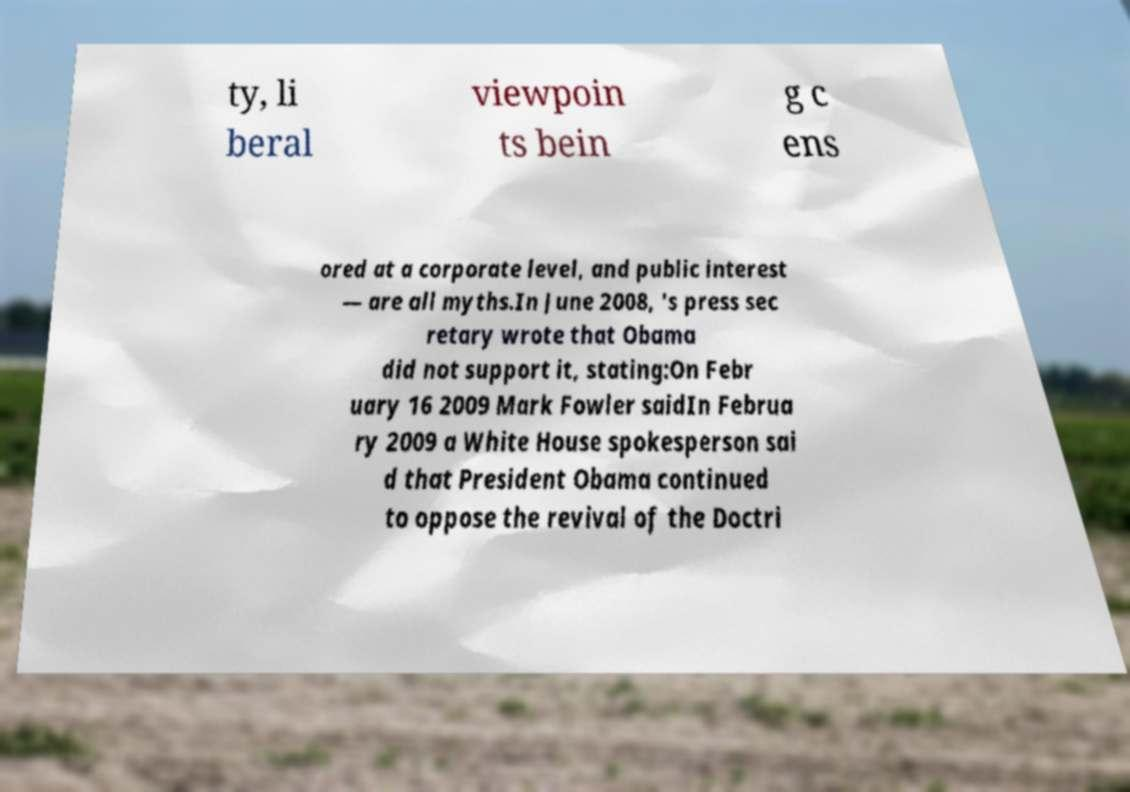Please identify and transcribe the text found in this image. ty, li beral viewpoin ts bein g c ens ored at a corporate level, and public interest — are all myths.In June 2008, 's press sec retary wrote that Obama did not support it, stating:On Febr uary 16 2009 Mark Fowler saidIn Februa ry 2009 a White House spokesperson sai d that President Obama continued to oppose the revival of the Doctri 